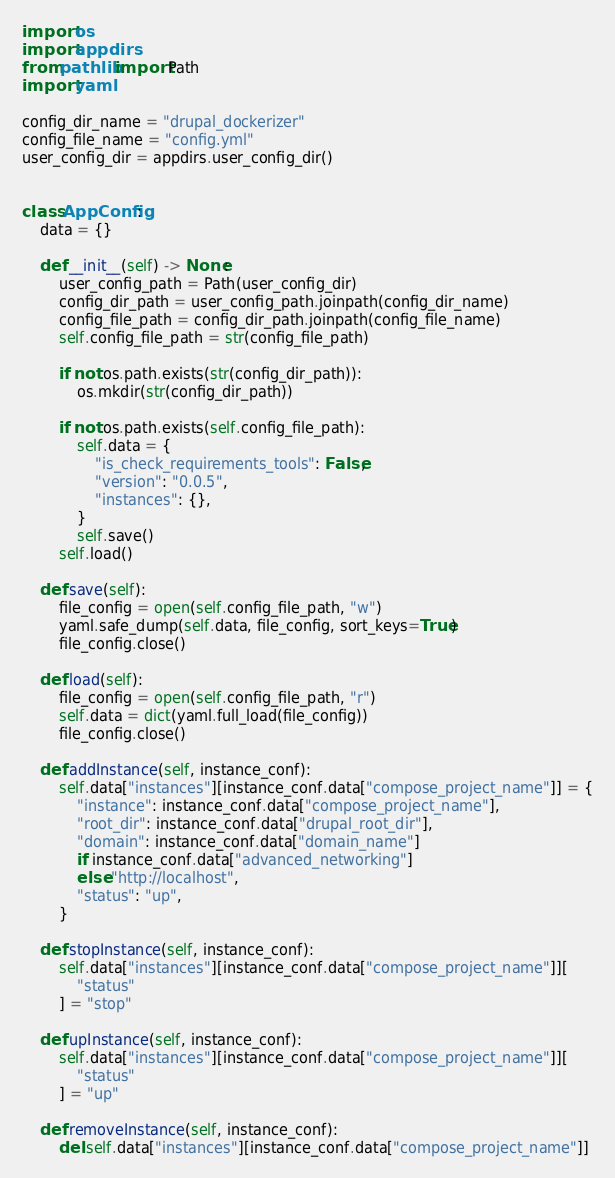<code> <loc_0><loc_0><loc_500><loc_500><_Python_>import os
import appdirs
from pathlib import Path
import yaml

config_dir_name = "drupal_dockerizer"
config_file_name = "config.yml"
user_config_dir = appdirs.user_config_dir()


class AppConfig:
    data = {}

    def __init__(self) -> None:
        user_config_path = Path(user_config_dir)
        config_dir_path = user_config_path.joinpath(config_dir_name)
        config_file_path = config_dir_path.joinpath(config_file_name)
        self.config_file_path = str(config_file_path)

        if not os.path.exists(str(config_dir_path)):
            os.mkdir(str(config_dir_path))

        if not os.path.exists(self.config_file_path):
            self.data = {
                "is_check_requirements_tools": False,
                "version": "0.0.5",
                "instances": {},
            }
            self.save()
        self.load()

    def save(self):
        file_config = open(self.config_file_path, "w")
        yaml.safe_dump(self.data, file_config, sort_keys=True)
        file_config.close()

    def load(self):
        file_config = open(self.config_file_path, "r")
        self.data = dict(yaml.full_load(file_config))
        file_config.close()

    def addInstance(self, instance_conf):
        self.data["instances"][instance_conf.data["compose_project_name"]] = {
            "instance": instance_conf.data["compose_project_name"],
            "root_dir": instance_conf.data["drupal_root_dir"],
            "domain": instance_conf.data["domain_name"]
            if instance_conf.data["advanced_networking"]
            else "http://localhost",
            "status": "up",
        }

    def stopInstance(self, instance_conf):
        self.data["instances"][instance_conf.data["compose_project_name"]][
            "status"
        ] = "stop"

    def upInstance(self, instance_conf):
        self.data["instances"][instance_conf.data["compose_project_name"]][
            "status"
        ] = "up"

    def removeInstance(self, instance_conf):
        del self.data["instances"][instance_conf.data["compose_project_name"]]
</code> 